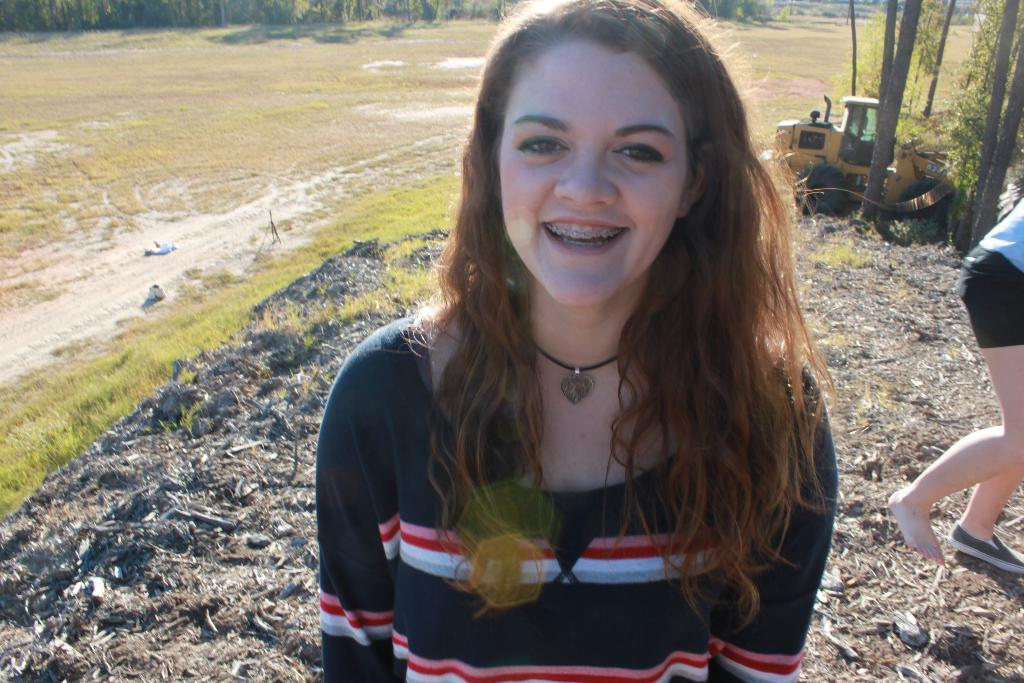What is the main subject of the image? There is a beautiful girl in the image. What is the girl's expression in the image? The girl is smiling in the image. What type of clothing is the girl wearing? The girl is wearing a t-shirt in the image. What can be seen on the left side of the image? There is grass on the left side of the image. What is located on the right side of the image? There is a yellow-colored vehicle on the right side of the image. What type of acoustics can be heard in the image? There is no information about any sounds or acoustics in the image, so it cannot be determined. How many spiders are visible on the girl's t-shirt in the image? There are no spiders visible on the girl's t-shirt in the image. 